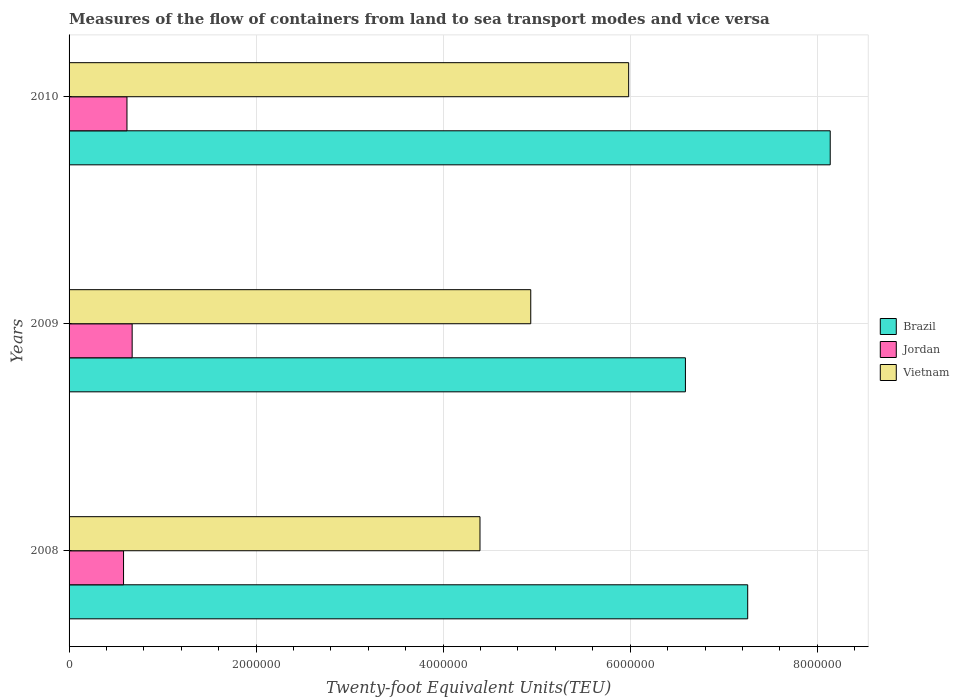How many different coloured bars are there?
Keep it short and to the point. 3. Are the number of bars per tick equal to the number of legend labels?
Your answer should be compact. Yes. Are the number of bars on each tick of the Y-axis equal?
Offer a very short reply. Yes. How many bars are there on the 1st tick from the bottom?
Your answer should be compact. 3. What is the label of the 3rd group of bars from the top?
Ensure brevity in your answer.  2008. In how many cases, is the number of bars for a given year not equal to the number of legend labels?
Ensure brevity in your answer.  0. What is the container port traffic in Brazil in 2008?
Your answer should be very brief. 7.26e+06. Across all years, what is the maximum container port traffic in Jordan?
Offer a terse response. 6.75e+05. Across all years, what is the minimum container port traffic in Vietnam?
Provide a short and direct response. 4.39e+06. What is the total container port traffic in Jordan in the graph?
Offer a very short reply. 1.88e+06. What is the difference between the container port traffic in Jordan in 2008 and that in 2009?
Your answer should be very brief. -9.20e+04. What is the difference between the container port traffic in Jordan in 2010 and the container port traffic in Brazil in 2008?
Make the answer very short. -6.64e+06. What is the average container port traffic in Jordan per year?
Offer a very short reply. 6.25e+05. In the year 2010, what is the difference between the container port traffic in Vietnam and container port traffic in Jordan?
Your answer should be compact. 5.36e+06. What is the ratio of the container port traffic in Vietnam in 2009 to that in 2010?
Your answer should be very brief. 0.83. What is the difference between the highest and the second highest container port traffic in Vietnam?
Give a very brief answer. 1.05e+06. What is the difference between the highest and the lowest container port traffic in Vietnam?
Ensure brevity in your answer.  1.59e+06. In how many years, is the container port traffic in Jordan greater than the average container port traffic in Jordan taken over all years?
Make the answer very short. 1. What does the 2nd bar from the top in 2008 represents?
Your answer should be very brief. Jordan. What does the 3rd bar from the bottom in 2008 represents?
Offer a very short reply. Vietnam. How many bars are there?
Ensure brevity in your answer.  9. Are all the bars in the graph horizontal?
Keep it short and to the point. Yes. How many years are there in the graph?
Ensure brevity in your answer.  3. What is the difference between two consecutive major ticks on the X-axis?
Your response must be concise. 2.00e+06. Are the values on the major ticks of X-axis written in scientific E-notation?
Provide a succinct answer. No. Where does the legend appear in the graph?
Provide a succinct answer. Center right. What is the title of the graph?
Offer a terse response. Measures of the flow of containers from land to sea transport modes and vice versa. Does "Panama" appear as one of the legend labels in the graph?
Provide a short and direct response. No. What is the label or title of the X-axis?
Provide a succinct answer. Twenty-foot Equivalent Units(TEU). What is the label or title of the Y-axis?
Your answer should be very brief. Years. What is the Twenty-foot Equivalent Units(TEU) of Brazil in 2008?
Offer a terse response. 7.26e+06. What is the Twenty-foot Equivalent Units(TEU) of Jordan in 2008?
Make the answer very short. 5.83e+05. What is the Twenty-foot Equivalent Units(TEU) of Vietnam in 2008?
Keep it short and to the point. 4.39e+06. What is the Twenty-foot Equivalent Units(TEU) of Brazil in 2009?
Offer a terse response. 6.59e+06. What is the Twenty-foot Equivalent Units(TEU) in Jordan in 2009?
Make the answer very short. 6.75e+05. What is the Twenty-foot Equivalent Units(TEU) in Vietnam in 2009?
Provide a short and direct response. 4.94e+06. What is the Twenty-foot Equivalent Units(TEU) in Brazil in 2010?
Provide a short and direct response. 8.14e+06. What is the Twenty-foot Equivalent Units(TEU) of Jordan in 2010?
Ensure brevity in your answer.  6.19e+05. What is the Twenty-foot Equivalent Units(TEU) of Vietnam in 2010?
Make the answer very short. 5.98e+06. Across all years, what is the maximum Twenty-foot Equivalent Units(TEU) of Brazil?
Make the answer very short. 8.14e+06. Across all years, what is the maximum Twenty-foot Equivalent Units(TEU) in Jordan?
Your answer should be very brief. 6.75e+05. Across all years, what is the maximum Twenty-foot Equivalent Units(TEU) in Vietnam?
Make the answer very short. 5.98e+06. Across all years, what is the minimum Twenty-foot Equivalent Units(TEU) of Brazil?
Your answer should be very brief. 6.59e+06. Across all years, what is the minimum Twenty-foot Equivalent Units(TEU) in Jordan?
Offer a terse response. 5.83e+05. Across all years, what is the minimum Twenty-foot Equivalent Units(TEU) of Vietnam?
Offer a very short reply. 4.39e+06. What is the total Twenty-foot Equivalent Units(TEU) in Brazil in the graph?
Provide a short and direct response. 2.20e+07. What is the total Twenty-foot Equivalent Units(TEU) of Jordan in the graph?
Your response must be concise. 1.88e+06. What is the total Twenty-foot Equivalent Units(TEU) in Vietnam in the graph?
Your response must be concise. 1.53e+07. What is the difference between the Twenty-foot Equivalent Units(TEU) in Brazil in 2008 and that in 2009?
Ensure brevity in your answer.  6.66e+05. What is the difference between the Twenty-foot Equivalent Units(TEU) in Jordan in 2008 and that in 2009?
Offer a terse response. -9.20e+04. What is the difference between the Twenty-foot Equivalent Units(TEU) in Vietnam in 2008 and that in 2009?
Your answer should be compact. -5.43e+05. What is the difference between the Twenty-foot Equivalent Units(TEU) of Brazil in 2008 and that in 2010?
Make the answer very short. -8.82e+05. What is the difference between the Twenty-foot Equivalent Units(TEU) in Jordan in 2008 and that in 2010?
Offer a very short reply. -3.65e+04. What is the difference between the Twenty-foot Equivalent Units(TEU) in Vietnam in 2008 and that in 2010?
Offer a terse response. -1.59e+06. What is the difference between the Twenty-foot Equivalent Units(TEU) in Brazil in 2009 and that in 2010?
Offer a very short reply. -1.55e+06. What is the difference between the Twenty-foot Equivalent Units(TEU) of Jordan in 2009 and that in 2010?
Offer a very short reply. 5.55e+04. What is the difference between the Twenty-foot Equivalent Units(TEU) in Vietnam in 2009 and that in 2010?
Keep it short and to the point. -1.05e+06. What is the difference between the Twenty-foot Equivalent Units(TEU) in Brazil in 2008 and the Twenty-foot Equivalent Units(TEU) in Jordan in 2009?
Your response must be concise. 6.58e+06. What is the difference between the Twenty-foot Equivalent Units(TEU) in Brazil in 2008 and the Twenty-foot Equivalent Units(TEU) in Vietnam in 2009?
Provide a short and direct response. 2.32e+06. What is the difference between the Twenty-foot Equivalent Units(TEU) in Jordan in 2008 and the Twenty-foot Equivalent Units(TEU) in Vietnam in 2009?
Ensure brevity in your answer.  -4.35e+06. What is the difference between the Twenty-foot Equivalent Units(TEU) in Brazil in 2008 and the Twenty-foot Equivalent Units(TEU) in Jordan in 2010?
Provide a succinct answer. 6.64e+06. What is the difference between the Twenty-foot Equivalent Units(TEU) in Brazil in 2008 and the Twenty-foot Equivalent Units(TEU) in Vietnam in 2010?
Keep it short and to the point. 1.27e+06. What is the difference between the Twenty-foot Equivalent Units(TEU) in Jordan in 2008 and the Twenty-foot Equivalent Units(TEU) in Vietnam in 2010?
Ensure brevity in your answer.  -5.40e+06. What is the difference between the Twenty-foot Equivalent Units(TEU) of Brazil in 2009 and the Twenty-foot Equivalent Units(TEU) of Jordan in 2010?
Keep it short and to the point. 5.97e+06. What is the difference between the Twenty-foot Equivalent Units(TEU) in Brazil in 2009 and the Twenty-foot Equivalent Units(TEU) in Vietnam in 2010?
Ensure brevity in your answer.  6.07e+05. What is the difference between the Twenty-foot Equivalent Units(TEU) of Jordan in 2009 and the Twenty-foot Equivalent Units(TEU) of Vietnam in 2010?
Ensure brevity in your answer.  -5.31e+06. What is the average Twenty-foot Equivalent Units(TEU) in Brazil per year?
Provide a succinct answer. 7.33e+06. What is the average Twenty-foot Equivalent Units(TEU) in Jordan per year?
Offer a very short reply. 6.25e+05. What is the average Twenty-foot Equivalent Units(TEU) in Vietnam per year?
Ensure brevity in your answer.  5.10e+06. In the year 2008, what is the difference between the Twenty-foot Equivalent Units(TEU) in Brazil and Twenty-foot Equivalent Units(TEU) in Jordan?
Make the answer very short. 6.67e+06. In the year 2008, what is the difference between the Twenty-foot Equivalent Units(TEU) of Brazil and Twenty-foot Equivalent Units(TEU) of Vietnam?
Provide a short and direct response. 2.86e+06. In the year 2008, what is the difference between the Twenty-foot Equivalent Units(TEU) of Jordan and Twenty-foot Equivalent Units(TEU) of Vietnam?
Make the answer very short. -3.81e+06. In the year 2009, what is the difference between the Twenty-foot Equivalent Units(TEU) in Brazil and Twenty-foot Equivalent Units(TEU) in Jordan?
Keep it short and to the point. 5.92e+06. In the year 2009, what is the difference between the Twenty-foot Equivalent Units(TEU) in Brazil and Twenty-foot Equivalent Units(TEU) in Vietnam?
Make the answer very short. 1.65e+06. In the year 2009, what is the difference between the Twenty-foot Equivalent Units(TEU) of Jordan and Twenty-foot Equivalent Units(TEU) of Vietnam?
Your response must be concise. -4.26e+06. In the year 2010, what is the difference between the Twenty-foot Equivalent Units(TEU) in Brazil and Twenty-foot Equivalent Units(TEU) in Jordan?
Your answer should be very brief. 7.52e+06. In the year 2010, what is the difference between the Twenty-foot Equivalent Units(TEU) of Brazil and Twenty-foot Equivalent Units(TEU) of Vietnam?
Offer a terse response. 2.16e+06. In the year 2010, what is the difference between the Twenty-foot Equivalent Units(TEU) of Jordan and Twenty-foot Equivalent Units(TEU) of Vietnam?
Give a very brief answer. -5.36e+06. What is the ratio of the Twenty-foot Equivalent Units(TEU) in Brazil in 2008 to that in 2009?
Keep it short and to the point. 1.1. What is the ratio of the Twenty-foot Equivalent Units(TEU) of Jordan in 2008 to that in 2009?
Your response must be concise. 0.86. What is the ratio of the Twenty-foot Equivalent Units(TEU) in Vietnam in 2008 to that in 2009?
Give a very brief answer. 0.89. What is the ratio of the Twenty-foot Equivalent Units(TEU) of Brazil in 2008 to that in 2010?
Ensure brevity in your answer.  0.89. What is the ratio of the Twenty-foot Equivalent Units(TEU) in Jordan in 2008 to that in 2010?
Keep it short and to the point. 0.94. What is the ratio of the Twenty-foot Equivalent Units(TEU) of Vietnam in 2008 to that in 2010?
Keep it short and to the point. 0.73. What is the ratio of the Twenty-foot Equivalent Units(TEU) of Brazil in 2009 to that in 2010?
Keep it short and to the point. 0.81. What is the ratio of the Twenty-foot Equivalent Units(TEU) in Jordan in 2009 to that in 2010?
Provide a short and direct response. 1.09. What is the ratio of the Twenty-foot Equivalent Units(TEU) in Vietnam in 2009 to that in 2010?
Give a very brief answer. 0.82. What is the difference between the highest and the second highest Twenty-foot Equivalent Units(TEU) of Brazil?
Give a very brief answer. 8.82e+05. What is the difference between the highest and the second highest Twenty-foot Equivalent Units(TEU) in Jordan?
Offer a terse response. 5.55e+04. What is the difference between the highest and the second highest Twenty-foot Equivalent Units(TEU) in Vietnam?
Offer a very short reply. 1.05e+06. What is the difference between the highest and the lowest Twenty-foot Equivalent Units(TEU) of Brazil?
Keep it short and to the point. 1.55e+06. What is the difference between the highest and the lowest Twenty-foot Equivalent Units(TEU) in Jordan?
Your answer should be compact. 9.20e+04. What is the difference between the highest and the lowest Twenty-foot Equivalent Units(TEU) of Vietnam?
Your answer should be compact. 1.59e+06. 